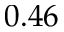<formula> <loc_0><loc_0><loc_500><loc_500>0 . 4 6</formula> 